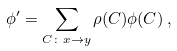Convert formula to latex. <formula><loc_0><loc_0><loc_500><loc_500>\phi ^ { \prime } = \sum _ { C \colon x \to y } \rho ( C ) \phi ( C ) \, ,</formula> 